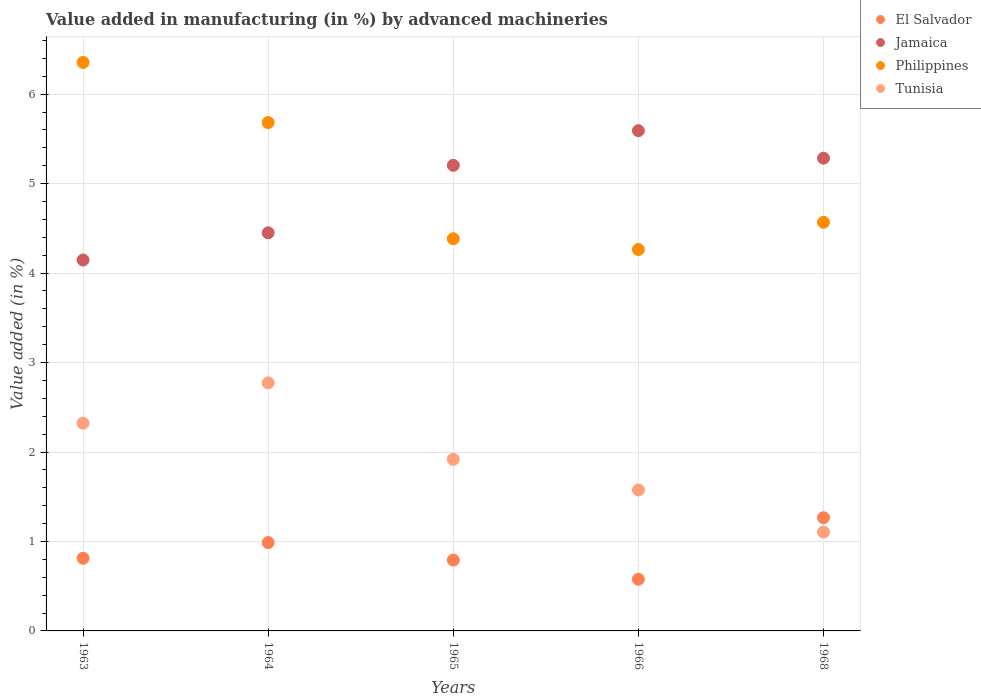Is the number of dotlines equal to the number of legend labels?
Ensure brevity in your answer.  Yes. What is the percentage of value added in manufacturing by advanced machineries in Jamaica in 1965?
Ensure brevity in your answer.  5.2. Across all years, what is the maximum percentage of value added in manufacturing by advanced machineries in Jamaica?
Provide a short and direct response. 5.59. Across all years, what is the minimum percentage of value added in manufacturing by advanced machineries in Tunisia?
Your answer should be compact. 1.1. In which year was the percentage of value added in manufacturing by advanced machineries in Philippines maximum?
Keep it short and to the point. 1963. In which year was the percentage of value added in manufacturing by advanced machineries in Philippines minimum?
Offer a terse response. 1966. What is the total percentage of value added in manufacturing by advanced machineries in Tunisia in the graph?
Your answer should be very brief. 9.69. What is the difference between the percentage of value added in manufacturing by advanced machineries in Philippines in 1963 and that in 1966?
Offer a very short reply. 2.09. What is the difference between the percentage of value added in manufacturing by advanced machineries in Jamaica in 1963 and the percentage of value added in manufacturing by advanced machineries in El Salvador in 1965?
Ensure brevity in your answer.  3.35. What is the average percentage of value added in manufacturing by advanced machineries in Philippines per year?
Give a very brief answer. 5.05. In the year 1968, what is the difference between the percentage of value added in manufacturing by advanced machineries in Philippines and percentage of value added in manufacturing by advanced machineries in Tunisia?
Make the answer very short. 3.46. In how many years, is the percentage of value added in manufacturing by advanced machineries in El Salvador greater than 5.4 %?
Offer a terse response. 0. What is the ratio of the percentage of value added in manufacturing by advanced machineries in Jamaica in 1963 to that in 1965?
Offer a very short reply. 0.8. Is the difference between the percentage of value added in manufacturing by advanced machineries in Philippines in 1963 and 1965 greater than the difference between the percentage of value added in manufacturing by advanced machineries in Tunisia in 1963 and 1965?
Provide a short and direct response. Yes. What is the difference between the highest and the second highest percentage of value added in manufacturing by advanced machineries in Philippines?
Your answer should be compact. 0.67. What is the difference between the highest and the lowest percentage of value added in manufacturing by advanced machineries in Philippines?
Your answer should be compact. 2.09. In how many years, is the percentage of value added in manufacturing by advanced machineries in Jamaica greater than the average percentage of value added in manufacturing by advanced machineries in Jamaica taken over all years?
Offer a very short reply. 3. Is the sum of the percentage of value added in manufacturing by advanced machineries in Tunisia in 1964 and 1966 greater than the maximum percentage of value added in manufacturing by advanced machineries in Jamaica across all years?
Ensure brevity in your answer.  No. Is it the case that in every year, the sum of the percentage of value added in manufacturing by advanced machineries in El Salvador and percentage of value added in manufacturing by advanced machineries in Philippines  is greater than the percentage of value added in manufacturing by advanced machineries in Tunisia?
Provide a succinct answer. Yes. Does the percentage of value added in manufacturing by advanced machineries in El Salvador monotonically increase over the years?
Offer a very short reply. No. Is the percentage of value added in manufacturing by advanced machineries in Jamaica strictly less than the percentage of value added in manufacturing by advanced machineries in Philippines over the years?
Keep it short and to the point. No. How many years are there in the graph?
Ensure brevity in your answer.  5. Are the values on the major ticks of Y-axis written in scientific E-notation?
Ensure brevity in your answer.  No. How many legend labels are there?
Keep it short and to the point. 4. What is the title of the graph?
Keep it short and to the point. Value added in manufacturing (in %) by advanced machineries. What is the label or title of the X-axis?
Give a very brief answer. Years. What is the label or title of the Y-axis?
Keep it short and to the point. Value added (in %). What is the Value added (in %) in El Salvador in 1963?
Ensure brevity in your answer.  0.81. What is the Value added (in %) in Jamaica in 1963?
Ensure brevity in your answer.  4.15. What is the Value added (in %) of Philippines in 1963?
Provide a short and direct response. 6.36. What is the Value added (in %) in Tunisia in 1963?
Provide a short and direct response. 2.32. What is the Value added (in %) in El Salvador in 1964?
Ensure brevity in your answer.  0.99. What is the Value added (in %) in Jamaica in 1964?
Offer a terse response. 4.45. What is the Value added (in %) of Philippines in 1964?
Provide a short and direct response. 5.68. What is the Value added (in %) of Tunisia in 1964?
Make the answer very short. 2.77. What is the Value added (in %) of El Salvador in 1965?
Offer a terse response. 0.79. What is the Value added (in %) in Jamaica in 1965?
Give a very brief answer. 5.2. What is the Value added (in %) in Philippines in 1965?
Your response must be concise. 4.38. What is the Value added (in %) of Tunisia in 1965?
Offer a terse response. 1.92. What is the Value added (in %) of El Salvador in 1966?
Provide a succinct answer. 0.58. What is the Value added (in %) in Jamaica in 1966?
Give a very brief answer. 5.59. What is the Value added (in %) in Philippines in 1966?
Give a very brief answer. 4.26. What is the Value added (in %) in Tunisia in 1966?
Offer a terse response. 1.58. What is the Value added (in %) in El Salvador in 1968?
Ensure brevity in your answer.  1.27. What is the Value added (in %) of Jamaica in 1968?
Provide a succinct answer. 5.28. What is the Value added (in %) in Philippines in 1968?
Provide a succinct answer. 4.57. What is the Value added (in %) of Tunisia in 1968?
Your response must be concise. 1.1. Across all years, what is the maximum Value added (in %) in El Salvador?
Your answer should be compact. 1.27. Across all years, what is the maximum Value added (in %) of Jamaica?
Offer a terse response. 5.59. Across all years, what is the maximum Value added (in %) in Philippines?
Your answer should be very brief. 6.36. Across all years, what is the maximum Value added (in %) of Tunisia?
Your response must be concise. 2.77. Across all years, what is the minimum Value added (in %) in El Salvador?
Offer a very short reply. 0.58. Across all years, what is the minimum Value added (in %) of Jamaica?
Ensure brevity in your answer.  4.15. Across all years, what is the minimum Value added (in %) of Philippines?
Make the answer very short. 4.26. Across all years, what is the minimum Value added (in %) in Tunisia?
Provide a short and direct response. 1.1. What is the total Value added (in %) in El Salvador in the graph?
Offer a very short reply. 4.44. What is the total Value added (in %) of Jamaica in the graph?
Give a very brief answer. 24.68. What is the total Value added (in %) in Philippines in the graph?
Ensure brevity in your answer.  25.25. What is the total Value added (in %) of Tunisia in the graph?
Provide a short and direct response. 9.69. What is the difference between the Value added (in %) in El Salvador in 1963 and that in 1964?
Your answer should be compact. -0.18. What is the difference between the Value added (in %) in Jamaica in 1963 and that in 1964?
Your response must be concise. -0.3. What is the difference between the Value added (in %) in Philippines in 1963 and that in 1964?
Offer a very short reply. 0.67. What is the difference between the Value added (in %) of Tunisia in 1963 and that in 1964?
Offer a terse response. -0.45. What is the difference between the Value added (in %) of El Salvador in 1963 and that in 1965?
Your answer should be compact. 0.02. What is the difference between the Value added (in %) in Jamaica in 1963 and that in 1965?
Make the answer very short. -1.06. What is the difference between the Value added (in %) of Philippines in 1963 and that in 1965?
Offer a very short reply. 1.97. What is the difference between the Value added (in %) of Tunisia in 1963 and that in 1965?
Make the answer very short. 0.4. What is the difference between the Value added (in %) in El Salvador in 1963 and that in 1966?
Keep it short and to the point. 0.23. What is the difference between the Value added (in %) of Jamaica in 1963 and that in 1966?
Keep it short and to the point. -1.45. What is the difference between the Value added (in %) of Philippines in 1963 and that in 1966?
Provide a succinct answer. 2.09. What is the difference between the Value added (in %) in Tunisia in 1963 and that in 1966?
Your response must be concise. 0.75. What is the difference between the Value added (in %) in El Salvador in 1963 and that in 1968?
Offer a terse response. -0.45. What is the difference between the Value added (in %) of Jamaica in 1963 and that in 1968?
Ensure brevity in your answer.  -1.14. What is the difference between the Value added (in %) in Philippines in 1963 and that in 1968?
Your response must be concise. 1.79. What is the difference between the Value added (in %) in Tunisia in 1963 and that in 1968?
Your answer should be very brief. 1.22. What is the difference between the Value added (in %) of El Salvador in 1964 and that in 1965?
Offer a very short reply. 0.2. What is the difference between the Value added (in %) in Jamaica in 1964 and that in 1965?
Your response must be concise. -0.75. What is the difference between the Value added (in %) of Philippines in 1964 and that in 1965?
Your answer should be compact. 1.3. What is the difference between the Value added (in %) of Tunisia in 1964 and that in 1965?
Your response must be concise. 0.85. What is the difference between the Value added (in %) of El Salvador in 1964 and that in 1966?
Offer a terse response. 0.41. What is the difference between the Value added (in %) of Jamaica in 1964 and that in 1966?
Ensure brevity in your answer.  -1.14. What is the difference between the Value added (in %) in Philippines in 1964 and that in 1966?
Your response must be concise. 1.42. What is the difference between the Value added (in %) in Tunisia in 1964 and that in 1966?
Give a very brief answer. 1.2. What is the difference between the Value added (in %) of El Salvador in 1964 and that in 1968?
Make the answer very short. -0.28. What is the difference between the Value added (in %) in Jamaica in 1964 and that in 1968?
Your response must be concise. -0.83. What is the difference between the Value added (in %) of Philippines in 1964 and that in 1968?
Your answer should be compact. 1.11. What is the difference between the Value added (in %) in Tunisia in 1964 and that in 1968?
Ensure brevity in your answer.  1.67. What is the difference between the Value added (in %) of El Salvador in 1965 and that in 1966?
Give a very brief answer. 0.21. What is the difference between the Value added (in %) of Jamaica in 1965 and that in 1966?
Offer a terse response. -0.39. What is the difference between the Value added (in %) of Philippines in 1965 and that in 1966?
Offer a very short reply. 0.12. What is the difference between the Value added (in %) in Tunisia in 1965 and that in 1966?
Provide a succinct answer. 0.34. What is the difference between the Value added (in %) of El Salvador in 1965 and that in 1968?
Your answer should be very brief. -0.47. What is the difference between the Value added (in %) in Jamaica in 1965 and that in 1968?
Provide a short and direct response. -0.08. What is the difference between the Value added (in %) in Philippines in 1965 and that in 1968?
Make the answer very short. -0.18. What is the difference between the Value added (in %) of Tunisia in 1965 and that in 1968?
Ensure brevity in your answer.  0.81. What is the difference between the Value added (in %) in El Salvador in 1966 and that in 1968?
Give a very brief answer. -0.69. What is the difference between the Value added (in %) in Jamaica in 1966 and that in 1968?
Provide a succinct answer. 0.31. What is the difference between the Value added (in %) in Philippines in 1966 and that in 1968?
Your answer should be compact. -0.3. What is the difference between the Value added (in %) in Tunisia in 1966 and that in 1968?
Your response must be concise. 0.47. What is the difference between the Value added (in %) in El Salvador in 1963 and the Value added (in %) in Jamaica in 1964?
Your response must be concise. -3.64. What is the difference between the Value added (in %) in El Salvador in 1963 and the Value added (in %) in Philippines in 1964?
Ensure brevity in your answer.  -4.87. What is the difference between the Value added (in %) of El Salvador in 1963 and the Value added (in %) of Tunisia in 1964?
Your response must be concise. -1.96. What is the difference between the Value added (in %) of Jamaica in 1963 and the Value added (in %) of Philippines in 1964?
Your answer should be compact. -1.54. What is the difference between the Value added (in %) of Jamaica in 1963 and the Value added (in %) of Tunisia in 1964?
Give a very brief answer. 1.37. What is the difference between the Value added (in %) of Philippines in 1963 and the Value added (in %) of Tunisia in 1964?
Offer a terse response. 3.58. What is the difference between the Value added (in %) of El Salvador in 1963 and the Value added (in %) of Jamaica in 1965?
Keep it short and to the point. -4.39. What is the difference between the Value added (in %) in El Salvador in 1963 and the Value added (in %) in Philippines in 1965?
Keep it short and to the point. -3.57. What is the difference between the Value added (in %) of El Salvador in 1963 and the Value added (in %) of Tunisia in 1965?
Your answer should be compact. -1.11. What is the difference between the Value added (in %) of Jamaica in 1963 and the Value added (in %) of Philippines in 1965?
Your response must be concise. -0.24. What is the difference between the Value added (in %) of Jamaica in 1963 and the Value added (in %) of Tunisia in 1965?
Give a very brief answer. 2.23. What is the difference between the Value added (in %) of Philippines in 1963 and the Value added (in %) of Tunisia in 1965?
Provide a succinct answer. 4.44. What is the difference between the Value added (in %) in El Salvador in 1963 and the Value added (in %) in Jamaica in 1966?
Provide a succinct answer. -4.78. What is the difference between the Value added (in %) of El Salvador in 1963 and the Value added (in %) of Philippines in 1966?
Provide a short and direct response. -3.45. What is the difference between the Value added (in %) in El Salvador in 1963 and the Value added (in %) in Tunisia in 1966?
Keep it short and to the point. -0.76. What is the difference between the Value added (in %) of Jamaica in 1963 and the Value added (in %) of Philippines in 1966?
Your response must be concise. -0.12. What is the difference between the Value added (in %) in Jamaica in 1963 and the Value added (in %) in Tunisia in 1966?
Offer a very short reply. 2.57. What is the difference between the Value added (in %) in Philippines in 1963 and the Value added (in %) in Tunisia in 1966?
Your response must be concise. 4.78. What is the difference between the Value added (in %) in El Salvador in 1963 and the Value added (in %) in Jamaica in 1968?
Offer a terse response. -4.47. What is the difference between the Value added (in %) of El Salvador in 1963 and the Value added (in %) of Philippines in 1968?
Your answer should be very brief. -3.76. What is the difference between the Value added (in %) in El Salvador in 1963 and the Value added (in %) in Tunisia in 1968?
Offer a very short reply. -0.29. What is the difference between the Value added (in %) in Jamaica in 1963 and the Value added (in %) in Philippines in 1968?
Provide a short and direct response. -0.42. What is the difference between the Value added (in %) of Jamaica in 1963 and the Value added (in %) of Tunisia in 1968?
Offer a terse response. 3.04. What is the difference between the Value added (in %) in Philippines in 1963 and the Value added (in %) in Tunisia in 1968?
Your response must be concise. 5.25. What is the difference between the Value added (in %) of El Salvador in 1964 and the Value added (in %) of Jamaica in 1965?
Provide a succinct answer. -4.22. What is the difference between the Value added (in %) of El Salvador in 1964 and the Value added (in %) of Philippines in 1965?
Ensure brevity in your answer.  -3.4. What is the difference between the Value added (in %) in El Salvador in 1964 and the Value added (in %) in Tunisia in 1965?
Make the answer very short. -0.93. What is the difference between the Value added (in %) of Jamaica in 1964 and the Value added (in %) of Philippines in 1965?
Your answer should be very brief. 0.07. What is the difference between the Value added (in %) in Jamaica in 1964 and the Value added (in %) in Tunisia in 1965?
Keep it short and to the point. 2.53. What is the difference between the Value added (in %) of Philippines in 1964 and the Value added (in %) of Tunisia in 1965?
Make the answer very short. 3.76. What is the difference between the Value added (in %) in El Salvador in 1964 and the Value added (in %) in Jamaica in 1966?
Ensure brevity in your answer.  -4.6. What is the difference between the Value added (in %) in El Salvador in 1964 and the Value added (in %) in Philippines in 1966?
Your response must be concise. -3.28. What is the difference between the Value added (in %) in El Salvador in 1964 and the Value added (in %) in Tunisia in 1966?
Your answer should be very brief. -0.59. What is the difference between the Value added (in %) in Jamaica in 1964 and the Value added (in %) in Philippines in 1966?
Your answer should be compact. 0.19. What is the difference between the Value added (in %) in Jamaica in 1964 and the Value added (in %) in Tunisia in 1966?
Ensure brevity in your answer.  2.87. What is the difference between the Value added (in %) of Philippines in 1964 and the Value added (in %) of Tunisia in 1966?
Keep it short and to the point. 4.11. What is the difference between the Value added (in %) of El Salvador in 1964 and the Value added (in %) of Jamaica in 1968?
Your answer should be very brief. -4.3. What is the difference between the Value added (in %) of El Salvador in 1964 and the Value added (in %) of Philippines in 1968?
Ensure brevity in your answer.  -3.58. What is the difference between the Value added (in %) of El Salvador in 1964 and the Value added (in %) of Tunisia in 1968?
Provide a short and direct response. -0.12. What is the difference between the Value added (in %) of Jamaica in 1964 and the Value added (in %) of Philippines in 1968?
Keep it short and to the point. -0.12. What is the difference between the Value added (in %) in Jamaica in 1964 and the Value added (in %) in Tunisia in 1968?
Make the answer very short. 3.35. What is the difference between the Value added (in %) of Philippines in 1964 and the Value added (in %) of Tunisia in 1968?
Your response must be concise. 4.58. What is the difference between the Value added (in %) in El Salvador in 1965 and the Value added (in %) in Jamaica in 1966?
Provide a succinct answer. -4.8. What is the difference between the Value added (in %) of El Salvador in 1965 and the Value added (in %) of Philippines in 1966?
Offer a terse response. -3.47. What is the difference between the Value added (in %) in El Salvador in 1965 and the Value added (in %) in Tunisia in 1966?
Offer a very short reply. -0.78. What is the difference between the Value added (in %) of Jamaica in 1965 and the Value added (in %) of Philippines in 1966?
Make the answer very short. 0.94. What is the difference between the Value added (in %) in Jamaica in 1965 and the Value added (in %) in Tunisia in 1966?
Ensure brevity in your answer.  3.63. What is the difference between the Value added (in %) in Philippines in 1965 and the Value added (in %) in Tunisia in 1966?
Provide a succinct answer. 2.81. What is the difference between the Value added (in %) in El Salvador in 1965 and the Value added (in %) in Jamaica in 1968?
Offer a terse response. -4.49. What is the difference between the Value added (in %) in El Salvador in 1965 and the Value added (in %) in Philippines in 1968?
Offer a terse response. -3.78. What is the difference between the Value added (in %) in El Salvador in 1965 and the Value added (in %) in Tunisia in 1968?
Make the answer very short. -0.31. What is the difference between the Value added (in %) in Jamaica in 1965 and the Value added (in %) in Philippines in 1968?
Ensure brevity in your answer.  0.64. What is the difference between the Value added (in %) in Jamaica in 1965 and the Value added (in %) in Tunisia in 1968?
Make the answer very short. 4.1. What is the difference between the Value added (in %) of Philippines in 1965 and the Value added (in %) of Tunisia in 1968?
Your answer should be compact. 3.28. What is the difference between the Value added (in %) of El Salvador in 1966 and the Value added (in %) of Jamaica in 1968?
Your answer should be very brief. -4.71. What is the difference between the Value added (in %) in El Salvador in 1966 and the Value added (in %) in Philippines in 1968?
Your answer should be compact. -3.99. What is the difference between the Value added (in %) in El Salvador in 1966 and the Value added (in %) in Tunisia in 1968?
Make the answer very short. -0.53. What is the difference between the Value added (in %) of Jamaica in 1966 and the Value added (in %) of Philippines in 1968?
Provide a short and direct response. 1.02. What is the difference between the Value added (in %) of Jamaica in 1966 and the Value added (in %) of Tunisia in 1968?
Your answer should be compact. 4.49. What is the difference between the Value added (in %) of Philippines in 1966 and the Value added (in %) of Tunisia in 1968?
Your answer should be very brief. 3.16. What is the average Value added (in %) of El Salvador per year?
Give a very brief answer. 0.89. What is the average Value added (in %) of Jamaica per year?
Your answer should be very brief. 4.94. What is the average Value added (in %) in Philippines per year?
Your answer should be compact. 5.05. What is the average Value added (in %) in Tunisia per year?
Provide a succinct answer. 1.94. In the year 1963, what is the difference between the Value added (in %) of El Salvador and Value added (in %) of Jamaica?
Give a very brief answer. -3.33. In the year 1963, what is the difference between the Value added (in %) of El Salvador and Value added (in %) of Philippines?
Offer a very short reply. -5.54. In the year 1963, what is the difference between the Value added (in %) of El Salvador and Value added (in %) of Tunisia?
Make the answer very short. -1.51. In the year 1963, what is the difference between the Value added (in %) of Jamaica and Value added (in %) of Philippines?
Your response must be concise. -2.21. In the year 1963, what is the difference between the Value added (in %) in Jamaica and Value added (in %) in Tunisia?
Make the answer very short. 1.82. In the year 1963, what is the difference between the Value added (in %) of Philippines and Value added (in %) of Tunisia?
Offer a very short reply. 4.03. In the year 1964, what is the difference between the Value added (in %) in El Salvador and Value added (in %) in Jamaica?
Provide a succinct answer. -3.46. In the year 1964, what is the difference between the Value added (in %) of El Salvador and Value added (in %) of Philippines?
Offer a very short reply. -4.69. In the year 1964, what is the difference between the Value added (in %) in El Salvador and Value added (in %) in Tunisia?
Your answer should be very brief. -1.78. In the year 1964, what is the difference between the Value added (in %) of Jamaica and Value added (in %) of Philippines?
Keep it short and to the point. -1.23. In the year 1964, what is the difference between the Value added (in %) of Jamaica and Value added (in %) of Tunisia?
Provide a succinct answer. 1.68. In the year 1964, what is the difference between the Value added (in %) of Philippines and Value added (in %) of Tunisia?
Your answer should be compact. 2.91. In the year 1965, what is the difference between the Value added (in %) in El Salvador and Value added (in %) in Jamaica?
Provide a short and direct response. -4.41. In the year 1965, what is the difference between the Value added (in %) in El Salvador and Value added (in %) in Philippines?
Provide a short and direct response. -3.59. In the year 1965, what is the difference between the Value added (in %) in El Salvador and Value added (in %) in Tunisia?
Your response must be concise. -1.13. In the year 1965, what is the difference between the Value added (in %) of Jamaica and Value added (in %) of Philippines?
Keep it short and to the point. 0.82. In the year 1965, what is the difference between the Value added (in %) of Jamaica and Value added (in %) of Tunisia?
Make the answer very short. 3.29. In the year 1965, what is the difference between the Value added (in %) in Philippines and Value added (in %) in Tunisia?
Your answer should be very brief. 2.47. In the year 1966, what is the difference between the Value added (in %) of El Salvador and Value added (in %) of Jamaica?
Your answer should be compact. -5.01. In the year 1966, what is the difference between the Value added (in %) in El Salvador and Value added (in %) in Philippines?
Offer a very short reply. -3.69. In the year 1966, what is the difference between the Value added (in %) in El Salvador and Value added (in %) in Tunisia?
Your response must be concise. -1. In the year 1966, what is the difference between the Value added (in %) in Jamaica and Value added (in %) in Philippines?
Provide a succinct answer. 1.33. In the year 1966, what is the difference between the Value added (in %) in Jamaica and Value added (in %) in Tunisia?
Ensure brevity in your answer.  4.02. In the year 1966, what is the difference between the Value added (in %) of Philippines and Value added (in %) of Tunisia?
Offer a terse response. 2.69. In the year 1968, what is the difference between the Value added (in %) of El Salvador and Value added (in %) of Jamaica?
Offer a terse response. -4.02. In the year 1968, what is the difference between the Value added (in %) of El Salvador and Value added (in %) of Philippines?
Your response must be concise. -3.3. In the year 1968, what is the difference between the Value added (in %) of El Salvador and Value added (in %) of Tunisia?
Make the answer very short. 0.16. In the year 1968, what is the difference between the Value added (in %) in Jamaica and Value added (in %) in Philippines?
Offer a very short reply. 0.72. In the year 1968, what is the difference between the Value added (in %) in Jamaica and Value added (in %) in Tunisia?
Ensure brevity in your answer.  4.18. In the year 1968, what is the difference between the Value added (in %) in Philippines and Value added (in %) in Tunisia?
Keep it short and to the point. 3.46. What is the ratio of the Value added (in %) of El Salvador in 1963 to that in 1964?
Provide a succinct answer. 0.82. What is the ratio of the Value added (in %) in Jamaica in 1963 to that in 1964?
Your answer should be very brief. 0.93. What is the ratio of the Value added (in %) of Philippines in 1963 to that in 1964?
Give a very brief answer. 1.12. What is the ratio of the Value added (in %) in Tunisia in 1963 to that in 1964?
Keep it short and to the point. 0.84. What is the ratio of the Value added (in %) in El Salvador in 1963 to that in 1965?
Provide a short and direct response. 1.03. What is the ratio of the Value added (in %) of Jamaica in 1963 to that in 1965?
Your answer should be very brief. 0.8. What is the ratio of the Value added (in %) of Philippines in 1963 to that in 1965?
Provide a short and direct response. 1.45. What is the ratio of the Value added (in %) of Tunisia in 1963 to that in 1965?
Ensure brevity in your answer.  1.21. What is the ratio of the Value added (in %) in El Salvador in 1963 to that in 1966?
Provide a short and direct response. 1.41. What is the ratio of the Value added (in %) in Jamaica in 1963 to that in 1966?
Ensure brevity in your answer.  0.74. What is the ratio of the Value added (in %) of Philippines in 1963 to that in 1966?
Provide a short and direct response. 1.49. What is the ratio of the Value added (in %) of Tunisia in 1963 to that in 1966?
Your answer should be compact. 1.47. What is the ratio of the Value added (in %) of El Salvador in 1963 to that in 1968?
Your response must be concise. 0.64. What is the ratio of the Value added (in %) in Jamaica in 1963 to that in 1968?
Ensure brevity in your answer.  0.78. What is the ratio of the Value added (in %) in Philippines in 1963 to that in 1968?
Your response must be concise. 1.39. What is the ratio of the Value added (in %) in Tunisia in 1963 to that in 1968?
Offer a terse response. 2.1. What is the ratio of the Value added (in %) in El Salvador in 1964 to that in 1965?
Your response must be concise. 1.25. What is the ratio of the Value added (in %) in Jamaica in 1964 to that in 1965?
Offer a terse response. 0.86. What is the ratio of the Value added (in %) of Philippines in 1964 to that in 1965?
Offer a very short reply. 1.3. What is the ratio of the Value added (in %) of Tunisia in 1964 to that in 1965?
Make the answer very short. 1.45. What is the ratio of the Value added (in %) in El Salvador in 1964 to that in 1966?
Make the answer very short. 1.71. What is the ratio of the Value added (in %) in Jamaica in 1964 to that in 1966?
Your answer should be compact. 0.8. What is the ratio of the Value added (in %) of Philippines in 1964 to that in 1966?
Keep it short and to the point. 1.33. What is the ratio of the Value added (in %) in Tunisia in 1964 to that in 1966?
Your answer should be very brief. 1.76. What is the ratio of the Value added (in %) of El Salvador in 1964 to that in 1968?
Provide a short and direct response. 0.78. What is the ratio of the Value added (in %) in Jamaica in 1964 to that in 1968?
Your answer should be very brief. 0.84. What is the ratio of the Value added (in %) of Philippines in 1964 to that in 1968?
Your answer should be very brief. 1.24. What is the ratio of the Value added (in %) in Tunisia in 1964 to that in 1968?
Your answer should be very brief. 2.51. What is the ratio of the Value added (in %) in El Salvador in 1965 to that in 1966?
Make the answer very short. 1.37. What is the ratio of the Value added (in %) of Jamaica in 1965 to that in 1966?
Give a very brief answer. 0.93. What is the ratio of the Value added (in %) of Philippines in 1965 to that in 1966?
Offer a very short reply. 1.03. What is the ratio of the Value added (in %) of Tunisia in 1965 to that in 1966?
Your answer should be very brief. 1.22. What is the ratio of the Value added (in %) in El Salvador in 1965 to that in 1968?
Provide a succinct answer. 0.63. What is the ratio of the Value added (in %) of Jamaica in 1965 to that in 1968?
Offer a very short reply. 0.98. What is the ratio of the Value added (in %) of Philippines in 1965 to that in 1968?
Your response must be concise. 0.96. What is the ratio of the Value added (in %) in Tunisia in 1965 to that in 1968?
Your answer should be compact. 1.74. What is the ratio of the Value added (in %) of El Salvador in 1966 to that in 1968?
Your response must be concise. 0.46. What is the ratio of the Value added (in %) in Jamaica in 1966 to that in 1968?
Provide a succinct answer. 1.06. What is the ratio of the Value added (in %) of Philippines in 1966 to that in 1968?
Keep it short and to the point. 0.93. What is the ratio of the Value added (in %) in Tunisia in 1966 to that in 1968?
Provide a succinct answer. 1.43. What is the difference between the highest and the second highest Value added (in %) in El Salvador?
Keep it short and to the point. 0.28. What is the difference between the highest and the second highest Value added (in %) in Jamaica?
Provide a succinct answer. 0.31. What is the difference between the highest and the second highest Value added (in %) in Philippines?
Your response must be concise. 0.67. What is the difference between the highest and the second highest Value added (in %) in Tunisia?
Ensure brevity in your answer.  0.45. What is the difference between the highest and the lowest Value added (in %) in El Salvador?
Your answer should be compact. 0.69. What is the difference between the highest and the lowest Value added (in %) in Jamaica?
Offer a terse response. 1.45. What is the difference between the highest and the lowest Value added (in %) of Philippines?
Provide a succinct answer. 2.09. What is the difference between the highest and the lowest Value added (in %) in Tunisia?
Give a very brief answer. 1.67. 